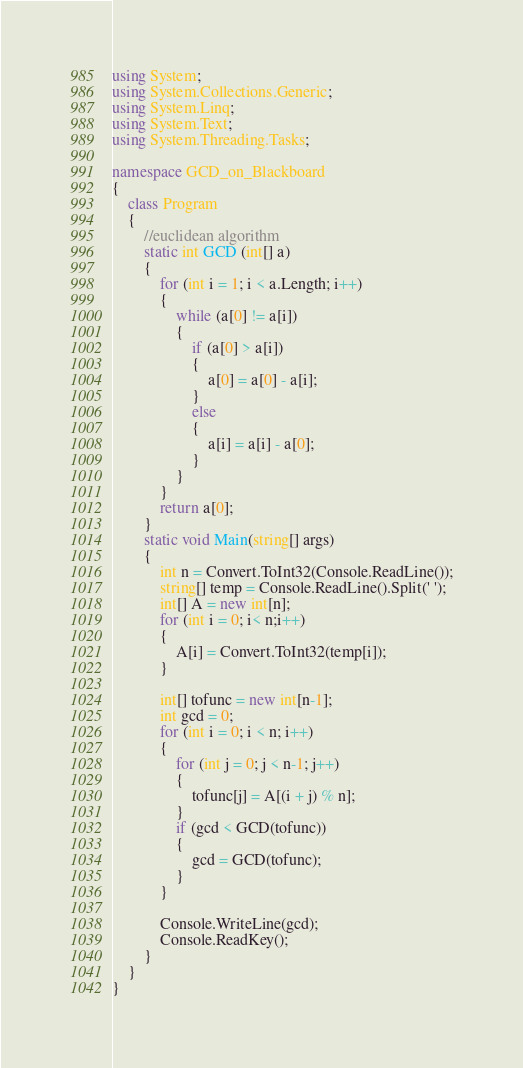Convert code to text. <code><loc_0><loc_0><loc_500><loc_500><_C#_>using System;
using System.Collections.Generic;
using System.Linq;
using System.Text;
using System.Threading.Tasks;

namespace GCD_on_Blackboard
{
    class Program
    {
        //euclidean algorithm
        static int GCD (int[] a)
        {
            for (int i = 1; i < a.Length; i++)
            {
                while (a[0] != a[i]) 
                {
                    if (a[0] > a[i])
                    {
                        a[0] = a[0] - a[i];
                    }
                    else
                    {
                        a[i] = a[i] - a[0];
                    }
                }        
            }
            return a[0];
        }
        static void Main(string[] args)
        {
            int n = Convert.ToInt32(Console.ReadLine());
            string[] temp = Console.ReadLine().Split(' ');
            int[] A = new int[n];
            for (int i = 0; i< n;i++)
            {
                A[i] = Convert.ToInt32(temp[i]);
            }

            int[] tofunc = new int[n-1];
            int gcd = 0;
            for (int i = 0; i < n; i++)
            {
                for (int j = 0; j < n-1; j++)
                {
                    tofunc[j] = A[(i + j) % n];
                }
                if (gcd < GCD(tofunc))
                {
                    gcd = GCD(tofunc);
                }
            }

            Console.WriteLine(gcd);
            Console.ReadKey();
        }
    }
}
</code> 